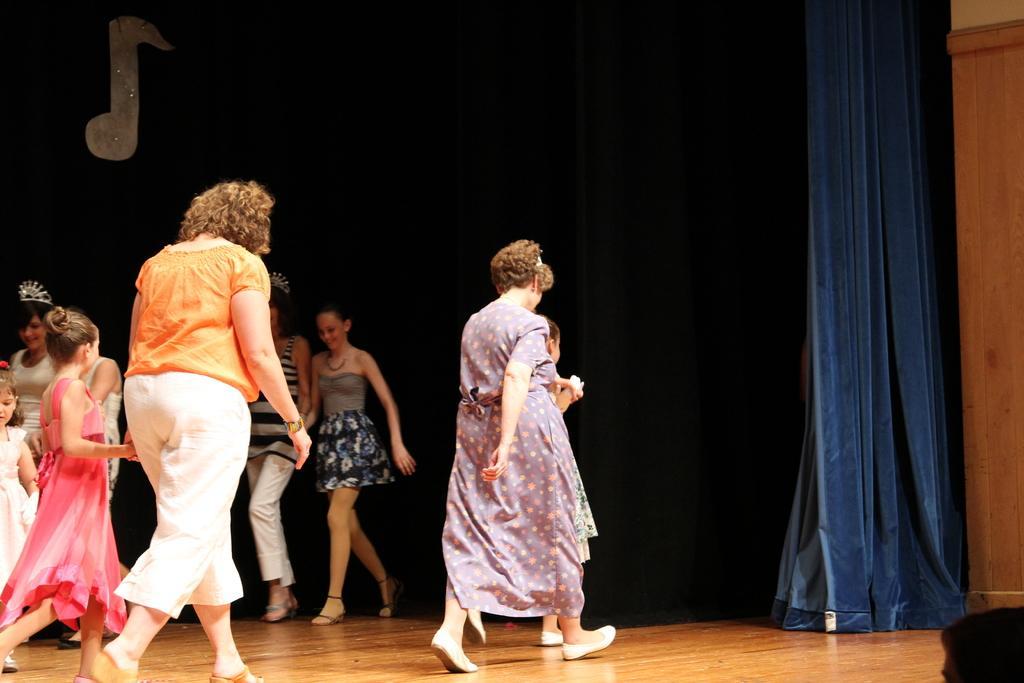How would you summarize this image in a sentence or two? In this image we can see a group of persons are standing on the stage, there are children standing, there is the blue curtain. 